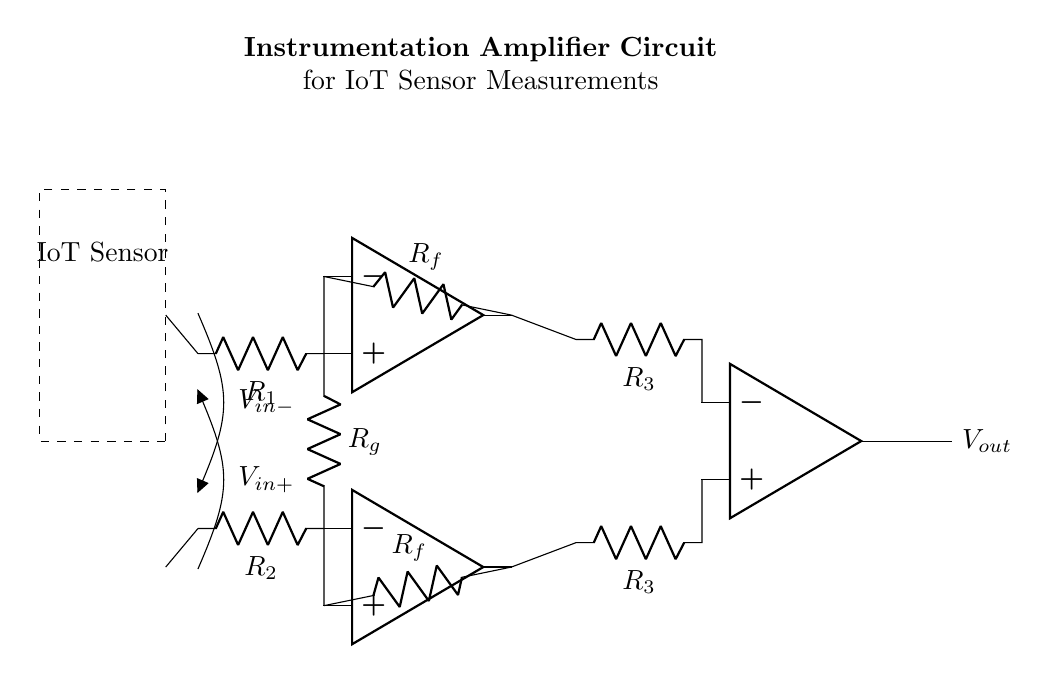What is the function of this circuit? The circuit is designed as an instrumentation amplifier, which is used to amplify low-level signals from sensors while rejecting common-mode noise.
Answer: Instrumentation amplifier What are the input voltages? The circuit has two input voltages labeled V_in+ and V_in-, which correspond to the non-inverting and inverting inputs of the first two operational amplifiers, respectively.
Answer: V_in+ and V_in- How many operational amplifiers are used in this circuit? There are three operational amplifiers shown in the circuit diagram, two for the input stage and one for the output stage.
Answer: Three What is the role of the feedback resistors? The feedback resistors, R_f, are used to set the gain of the instrumentation amplifier. They are connected between the output and inverting inputs of the operational amplifiers, controlling the feedback for amplification.
Answer: To set gain What is the purpose of R_g in the circuit? R_g connects the inverting input of the first operational amplifier to the non-inverting input of the second operational amplifier, and it helps to balance the gain for both inputs, improving the common-mode rejection.
Answer: Balance gain What is the output voltage labeled as in the diagram? The output voltage is labeled as V_out, which is the amplified signal from the instrumentation amplifier circuit.
Answer: V_out What type of sensors is this amplifier likely designed to work with? The circuit is intended for use with IoT sensors that generate low-level signals, requiring amplification for accurate measurements and processing.
Answer: IoT sensors 